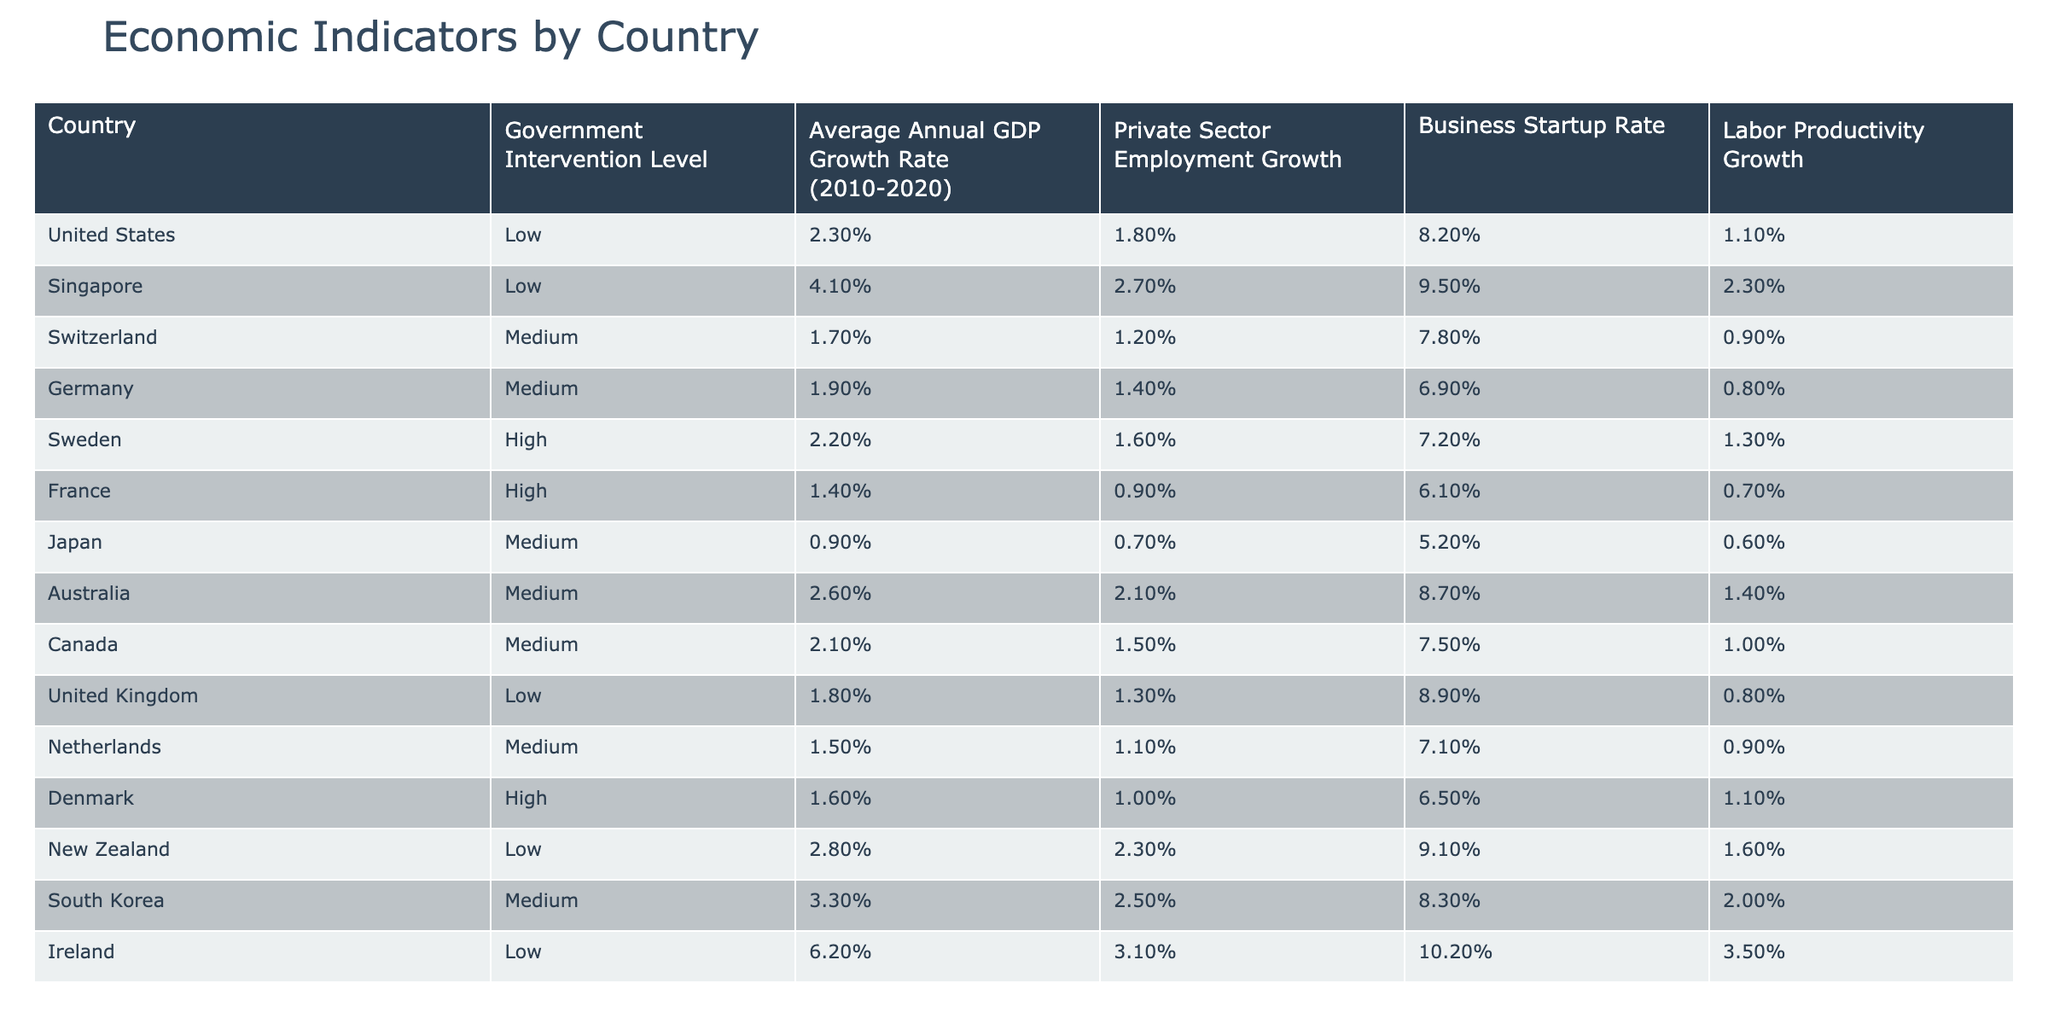What is the government intervention level in Germany? The table shows that Germany has a Medium level of government intervention indicated in the second column.
Answer: Medium Which country has the highest average annual GDP growth rate? By comparing the values in the third column, Ireland has the highest average annual GDP growth rate at 6.2%.
Answer: 6.2% What is the average annual GDP growth rate for countries with High government intervention? The average of the GDP growth rates for Sweden (2.2%), France (1.4%), and Denmark (1.6%) is calculated as follows: (2.2% + 1.4% + 1.6%)/3 = 1.733...%. Therefore, the average annual GDP growth rate is approximately 1.73%.
Answer: 1.73% Which country has the lowest labor productivity growth? The table displays Japan with a labor productivity growth rate of 0.6%, which is the lowest in the last column.
Answer: 0.6% Which country with Low government intervention shows the highest private sector employment growth? By examining the private sector employment growth column for Low government intervention countries, we see that Ireland has the highest rate at 3.1%.
Answer: 3.1% Is it true that Australia has a Medium level of government intervention? In the second column of the table, Australia is listed under the Medium category for government intervention level, confirming that the statement is true.
Answer: True What is the difference in business startup rates between Singapore and France? The business startup rate for Singapore is 9.5% and for France is 6.1%. The difference is calculated as 9.5% - 6.1% = 3.4%.
Answer: 3.4% What is the average labor productivity growth for countries with Low intervention? The labor productivity growth rates for Low intervention countries are: United States (1.1%), Singapore (2.3%), New Zealand (1.6%), and Ireland (3.5%). The average is computed as: (1.1% + 2.3% + 1.6% + 3.5%) / 4 = 2.12%.
Answer: 2.12% Considering all countries in the table, do higher levels of government intervention correlate with lower average annual GDP growth rates? Inspecting the three intervention levels, the average GDP growth rates are High (1.73%), Medium (2.25%), and Low (approximately 2.54%). This suggests that lower government intervention correlates with higher GDP growth, indicating a negative correlation.
Answer: Yes What is the average ratio of private sector employment growth to business startup rate across all countries listed? To find this, sum the private sector employment growth (calculating for each country) and divide it by the sum of business startup rates. The total private sector employment growth is approximately 21.5% and business startup rate is approximately 76.8%. Hence, the average ratio is 21.5%/76.8% ≈ 0.28.
Answer: 0.28 